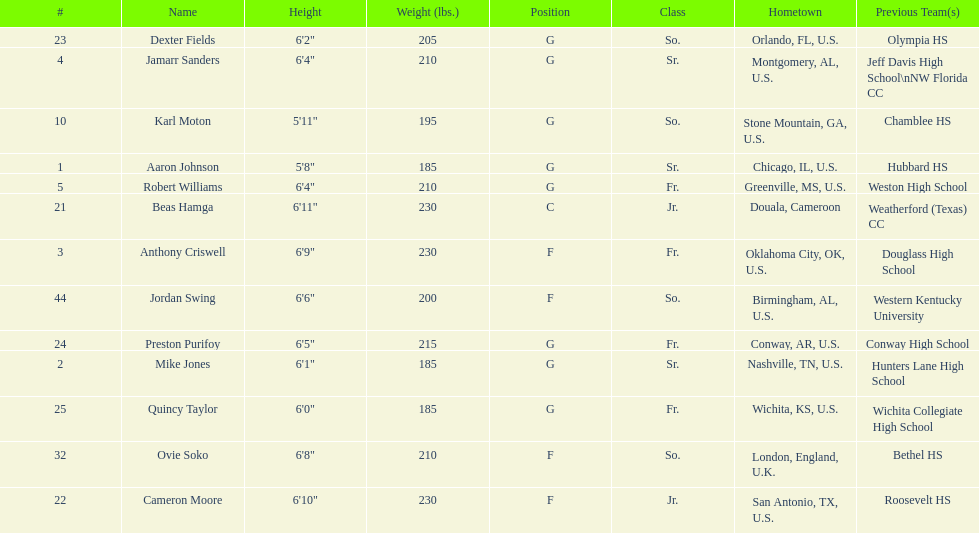Other than soko, tell me a player who is not from the us. Beas Hamga. 